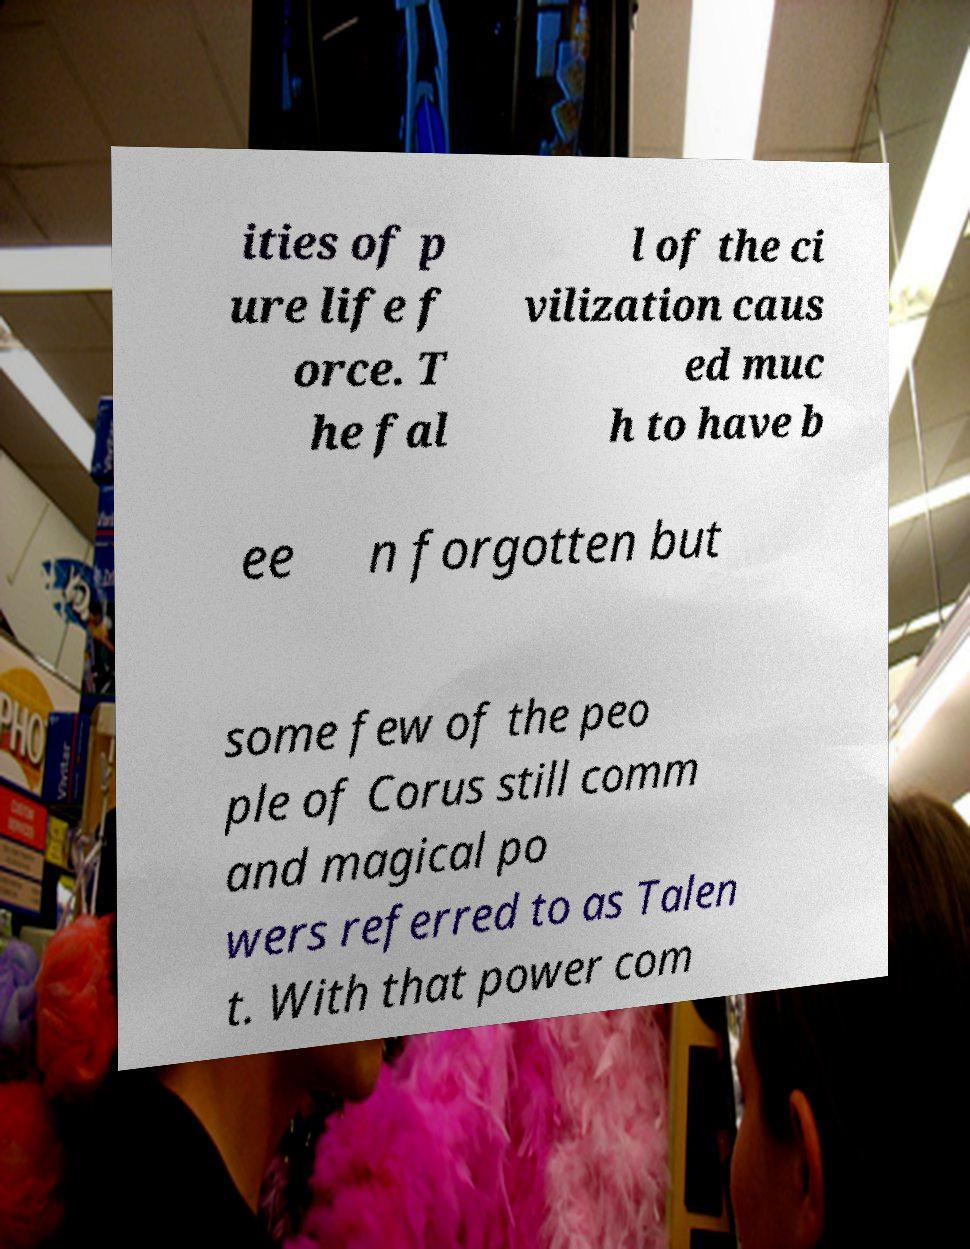Could you assist in decoding the text presented in this image and type it out clearly? ities of p ure life f orce. T he fal l of the ci vilization caus ed muc h to have b ee n forgotten but some few of the peo ple of Corus still comm and magical po wers referred to as Talen t. With that power com 